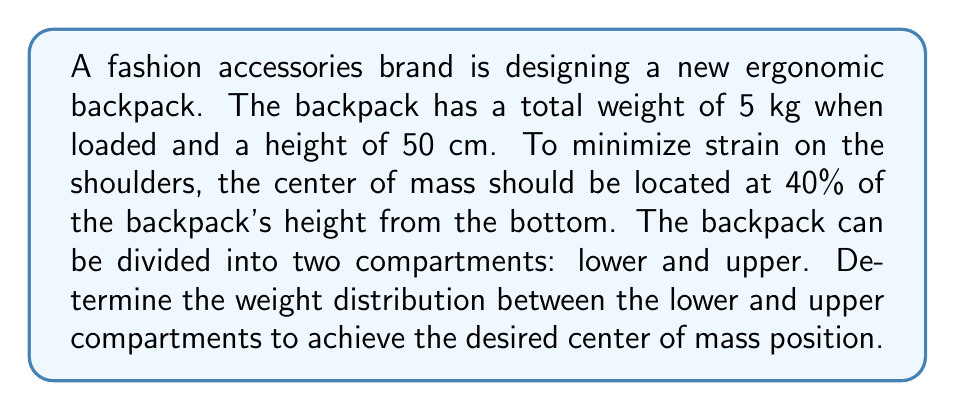Could you help me with this problem? Let's approach this step-by-step:

1) Let $x$ be the weight of the lower compartment and $y$ be the weight of the upper compartment.

2) We know that the total weight is 5 kg, so:

   $$x + y = 5$$

3) The center of mass (COM) should be at 40% of the height from the bottom, which is:

   $$0.4 \times 50 \text{ cm} = 20 \text{ cm}$$

4) We can use the principle that the total moment about the bottom of the backpack should be equal to the product of total weight and COM height:

   $$x(0) + y(50) = 5(20)$$

   The lower compartment's moment is $x(0)$ because its center is at the bottom.

5) Simplifying:

   $$50y = 100$$
   $$y = 2$$

6) Substituting this back into the equation from step 2:

   $$x + 2 = 5$$
   $$x = 3$$

7) Therefore, the lower compartment should weigh 3 kg and the upper compartment should weigh 2 kg.

8) We can verify:
   $$\frac{3(0) + 2(50)}{5} = 20 \text{ cm}$$

   This confirms that the center of mass is indeed at 20 cm, or 40% of the height.
Answer: Lower compartment: 3 kg, Upper compartment: 2 kg 